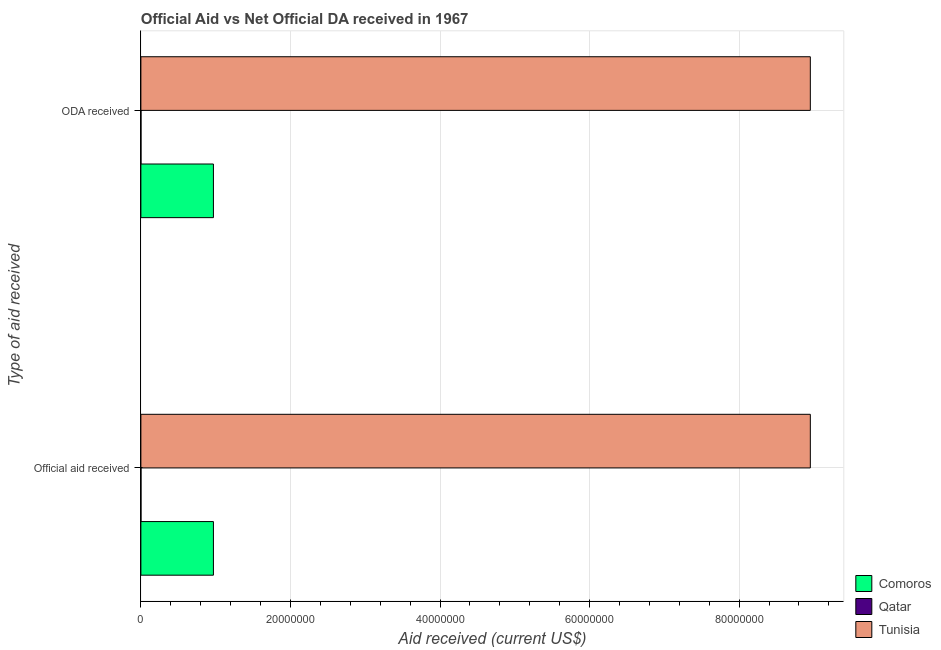How many different coloured bars are there?
Make the answer very short. 3. How many groups of bars are there?
Provide a succinct answer. 2. How many bars are there on the 1st tick from the bottom?
Keep it short and to the point. 3. What is the label of the 1st group of bars from the top?
Ensure brevity in your answer.  ODA received. What is the official aid received in Tunisia?
Your answer should be compact. 8.95e+07. Across all countries, what is the maximum official aid received?
Keep it short and to the point. 8.95e+07. Across all countries, what is the minimum oda received?
Your answer should be compact. 10000. In which country was the official aid received maximum?
Your answer should be compact. Tunisia. In which country was the oda received minimum?
Your answer should be very brief. Qatar. What is the total oda received in the graph?
Ensure brevity in your answer.  9.92e+07. What is the difference between the official aid received in Comoros and that in Tunisia?
Offer a very short reply. -7.98e+07. What is the difference between the official aid received in Tunisia and the oda received in Comoros?
Make the answer very short. 7.98e+07. What is the average official aid received per country?
Provide a succinct answer. 3.31e+07. What is the difference between the official aid received and oda received in Tunisia?
Offer a terse response. 0. In how many countries, is the oda received greater than 56000000 US$?
Give a very brief answer. 1. What is the ratio of the official aid received in Qatar to that in Comoros?
Give a very brief answer. 0. What does the 3rd bar from the top in Official aid received represents?
Ensure brevity in your answer.  Comoros. What does the 1st bar from the bottom in ODA received represents?
Provide a succinct answer. Comoros. How many bars are there?
Make the answer very short. 6. Are all the bars in the graph horizontal?
Make the answer very short. Yes. How many countries are there in the graph?
Your answer should be compact. 3. What is the difference between two consecutive major ticks on the X-axis?
Provide a succinct answer. 2.00e+07. Where does the legend appear in the graph?
Your response must be concise. Bottom right. What is the title of the graph?
Offer a terse response. Official Aid vs Net Official DA received in 1967 . Does "Kazakhstan" appear as one of the legend labels in the graph?
Your answer should be very brief. No. What is the label or title of the X-axis?
Give a very brief answer. Aid received (current US$). What is the label or title of the Y-axis?
Your response must be concise. Type of aid received. What is the Aid received (current US$) of Comoros in Official aid received?
Provide a succinct answer. 9.70e+06. What is the Aid received (current US$) of Tunisia in Official aid received?
Give a very brief answer. 8.95e+07. What is the Aid received (current US$) in Comoros in ODA received?
Provide a succinct answer. 9.70e+06. What is the Aid received (current US$) in Tunisia in ODA received?
Give a very brief answer. 8.95e+07. Across all Type of aid received, what is the maximum Aid received (current US$) in Comoros?
Your answer should be compact. 9.70e+06. Across all Type of aid received, what is the maximum Aid received (current US$) of Tunisia?
Provide a succinct answer. 8.95e+07. Across all Type of aid received, what is the minimum Aid received (current US$) of Comoros?
Ensure brevity in your answer.  9.70e+06. Across all Type of aid received, what is the minimum Aid received (current US$) in Qatar?
Offer a very short reply. 10000. Across all Type of aid received, what is the minimum Aid received (current US$) in Tunisia?
Give a very brief answer. 8.95e+07. What is the total Aid received (current US$) in Comoros in the graph?
Your response must be concise. 1.94e+07. What is the total Aid received (current US$) in Tunisia in the graph?
Provide a succinct answer. 1.79e+08. What is the difference between the Aid received (current US$) in Comoros in Official aid received and that in ODA received?
Offer a terse response. 0. What is the difference between the Aid received (current US$) in Comoros in Official aid received and the Aid received (current US$) in Qatar in ODA received?
Your answer should be very brief. 9.69e+06. What is the difference between the Aid received (current US$) of Comoros in Official aid received and the Aid received (current US$) of Tunisia in ODA received?
Provide a short and direct response. -7.98e+07. What is the difference between the Aid received (current US$) of Qatar in Official aid received and the Aid received (current US$) of Tunisia in ODA received?
Offer a terse response. -8.95e+07. What is the average Aid received (current US$) of Comoros per Type of aid received?
Your answer should be compact. 9.70e+06. What is the average Aid received (current US$) in Tunisia per Type of aid received?
Make the answer very short. 8.95e+07. What is the difference between the Aid received (current US$) of Comoros and Aid received (current US$) of Qatar in Official aid received?
Your answer should be compact. 9.69e+06. What is the difference between the Aid received (current US$) in Comoros and Aid received (current US$) in Tunisia in Official aid received?
Provide a short and direct response. -7.98e+07. What is the difference between the Aid received (current US$) in Qatar and Aid received (current US$) in Tunisia in Official aid received?
Make the answer very short. -8.95e+07. What is the difference between the Aid received (current US$) of Comoros and Aid received (current US$) of Qatar in ODA received?
Offer a very short reply. 9.69e+06. What is the difference between the Aid received (current US$) in Comoros and Aid received (current US$) in Tunisia in ODA received?
Offer a terse response. -7.98e+07. What is the difference between the Aid received (current US$) of Qatar and Aid received (current US$) of Tunisia in ODA received?
Your response must be concise. -8.95e+07. What is the difference between the highest and the lowest Aid received (current US$) of Qatar?
Keep it short and to the point. 0. 